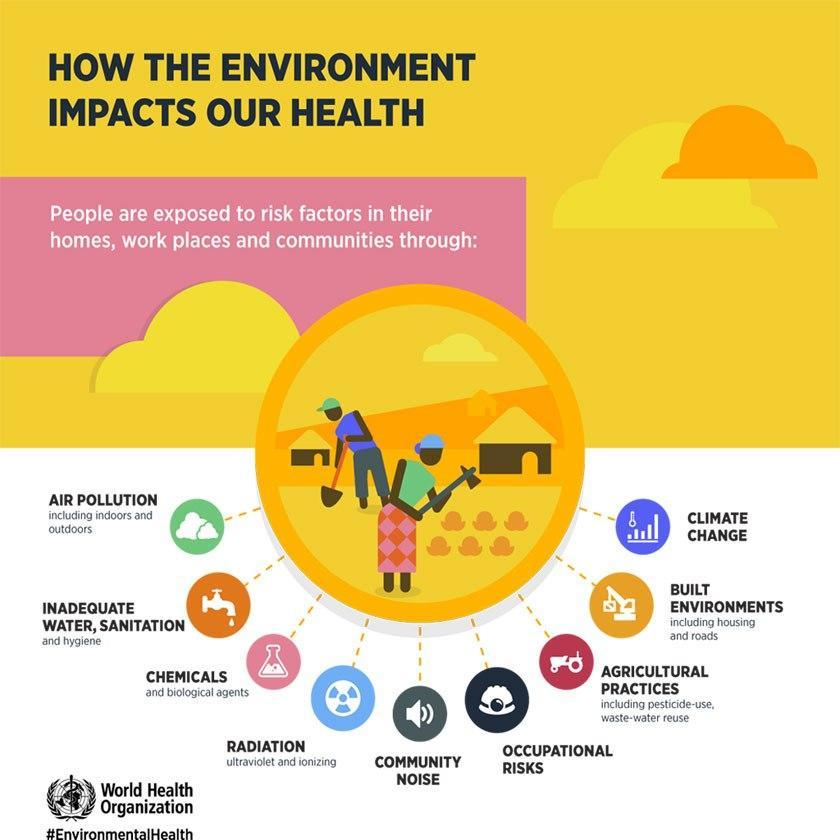how many people are there in the vector representation?
Answer the question with a short phrase. 2 what is the color of the main title - yellow, blue or black? black what has been represented by the symbol of speaker? community noise what is the second last factor given in the list? built environments 